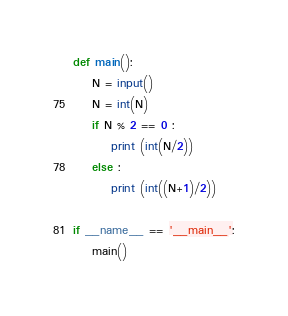Convert code to text. <code><loc_0><loc_0><loc_500><loc_500><_Python_>def main():
    N = input()
    N = int(N)
    if N % 2 == 0 :
        print (int(N/2))
    else :
        print (int((N+1)/2))

if __name__ == '__main__':
    main()</code> 